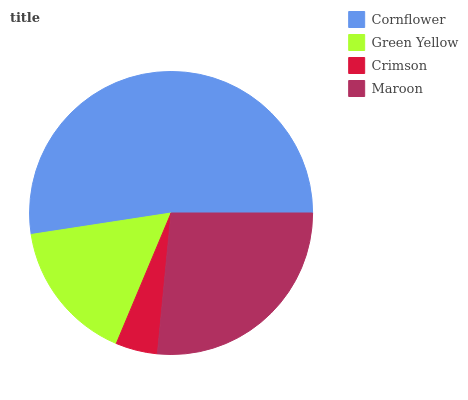Is Crimson the minimum?
Answer yes or no. Yes. Is Cornflower the maximum?
Answer yes or no. Yes. Is Green Yellow the minimum?
Answer yes or no. No. Is Green Yellow the maximum?
Answer yes or no. No. Is Cornflower greater than Green Yellow?
Answer yes or no. Yes. Is Green Yellow less than Cornflower?
Answer yes or no. Yes. Is Green Yellow greater than Cornflower?
Answer yes or no. No. Is Cornflower less than Green Yellow?
Answer yes or no. No. Is Maroon the high median?
Answer yes or no. Yes. Is Green Yellow the low median?
Answer yes or no. Yes. Is Crimson the high median?
Answer yes or no. No. Is Cornflower the low median?
Answer yes or no. No. 